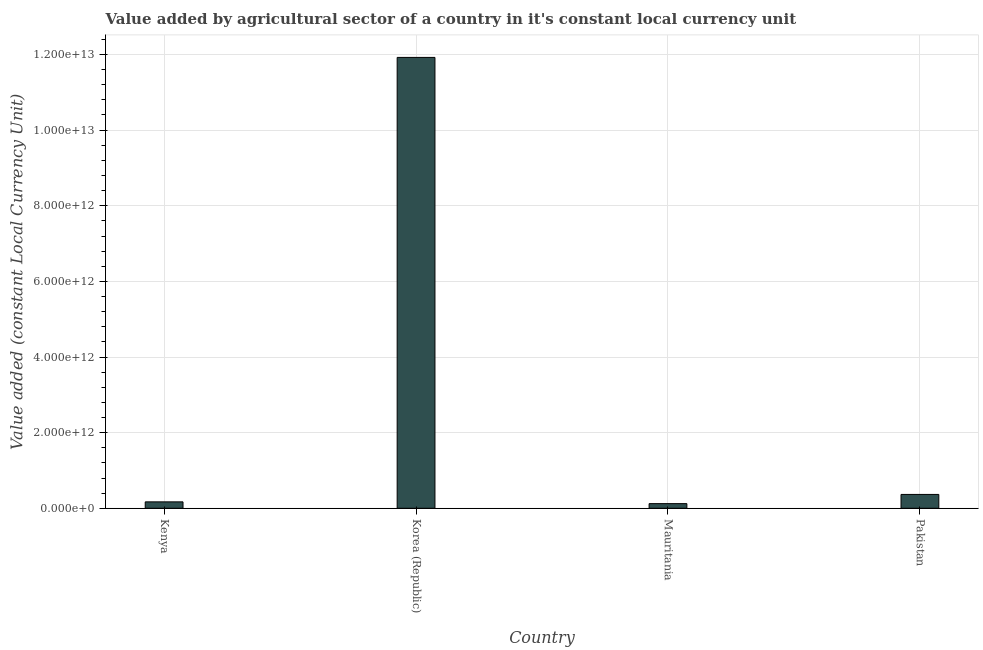Does the graph contain any zero values?
Keep it short and to the point. No. What is the title of the graph?
Make the answer very short. Value added by agricultural sector of a country in it's constant local currency unit. What is the label or title of the Y-axis?
Provide a short and direct response. Value added (constant Local Currency Unit). What is the value added by agriculture sector in Korea (Republic)?
Your answer should be compact. 1.19e+13. Across all countries, what is the maximum value added by agriculture sector?
Your response must be concise. 1.19e+13. Across all countries, what is the minimum value added by agriculture sector?
Ensure brevity in your answer.  1.22e+11. In which country was the value added by agriculture sector minimum?
Your answer should be compact. Mauritania. What is the sum of the value added by agriculture sector?
Your response must be concise. 1.26e+13. What is the difference between the value added by agriculture sector in Kenya and Mauritania?
Offer a very short reply. 4.71e+1. What is the average value added by agriculture sector per country?
Give a very brief answer. 3.15e+12. What is the median value added by agriculture sector?
Your response must be concise. 2.68e+11. In how many countries, is the value added by agriculture sector greater than 8800000000000 LCU?
Offer a terse response. 1. What is the ratio of the value added by agriculture sector in Kenya to that in Korea (Republic)?
Give a very brief answer. 0.01. Is the value added by agriculture sector in Kenya less than that in Mauritania?
Your answer should be compact. No. What is the difference between the highest and the second highest value added by agriculture sector?
Make the answer very short. 1.16e+13. What is the difference between the highest and the lowest value added by agriculture sector?
Provide a short and direct response. 1.18e+13. In how many countries, is the value added by agriculture sector greater than the average value added by agriculture sector taken over all countries?
Offer a terse response. 1. How many bars are there?
Provide a succinct answer. 4. Are all the bars in the graph horizontal?
Provide a succinct answer. No. What is the difference between two consecutive major ticks on the Y-axis?
Your response must be concise. 2.00e+12. What is the Value added (constant Local Currency Unit) of Kenya?
Keep it short and to the point. 1.69e+11. What is the Value added (constant Local Currency Unit) in Korea (Republic)?
Offer a very short reply. 1.19e+13. What is the Value added (constant Local Currency Unit) of Mauritania?
Provide a short and direct response. 1.22e+11. What is the Value added (constant Local Currency Unit) of Pakistan?
Make the answer very short. 3.66e+11. What is the difference between the Value added (constant Local Currency Unit) in Kenya and Korea (Republic)?
Keep it short and to the point. -1.18e+13. What is the difference between the Value added (constant Local Currency Unit) in Kenya and Mauritania?
Your response must be concise. 4.71e+1. What is the difference between the Value added (constant Local Currency Unit) in Kenya and Pakistan?
Offer a terse response. -1.96e+11. What is the difference between the Value added (constant Local Currency Unit) in Korea (Republic) and Mauritania?
Your answer should be very brief. 1.18e+13. What is the difference between the Value added (constant Local Currency Unit) in Korea (Republic) and Pakistan?
Give a very brief answer. 1.16e+13. What is the difference between the Value added (constant Local Currency Unit) in Mauritania and Pakistan?
Ensure brevity in your answer.  -2.43e+11. What is the ratio of the Value added (constant Local Currency Unit) in Kenya to that in Korea (Republic)?
Keep it short and to the point. 0.01. What is the ratio of the Value added (constant Local Currency Unit) in Kenya to that in Mauritania?
Your answer should be compact. 1.38. What is the ratio of the Value added (constant Local Currency Unit) in Kenya to that in Pakistan?
Offer a terse response. 0.46. What is the ratio of the Value added (constant Local Currency Unit) in Korea (Republic) to that in Mauritania?
Give a very brief answer. 97.39. What is the ratio of the Value added (constant Local Currency Unit) in Korea (Republic) to that in Pakistan?
Keep it short and to the point. 32.59. What is the ratio of the Value added (constant Local Currency Unit) in Mauritania to that in Pakistan?
Make the answer very short. 0.34. 